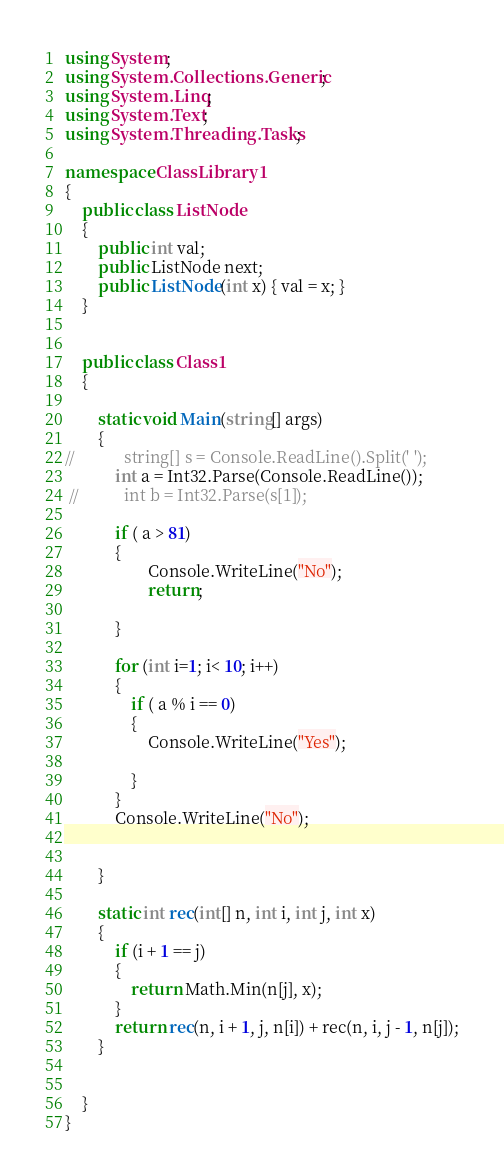Convert code to text. <code><loc_0><loc_0><loc_500><loc_500><_C#_>using System;
using System.Collections.Generic;
using System.Linq;
using System.Text;
using System.Threading.Tasks;

namespace ClassLibrary1
{
    public class ListNode
    {
        public int val;
        public ListNode next;
        public ListNode(int x) { val = x; }
    }


    public class Class1
    {

        static void Main(string[] args)
        {
//            string[] s = Console.ReadLine().Split(' ');
            int a = Int32.Parse(Console.ReadLine());
 //           int b = Int32.Parse(s[1]);

            if ( a > 81)
            {
                    Console.WriteLine("No");
                    return;

            }

            for (int i=1; i< 10; i++)
            {
                if ( a % i == 0)
                {
                    Console.WriteLine("Yes");

                }
            }
            Console.WriteLine("No");


        }

        static int rec(int[] n, int i, int j, int x)
        {
            if (i + 1 == j)
            {
                return Math.Min(n[j], x);
            }
            return rec(n, i + 1, j, n[i]) + rec(n, i, j - 1, n[j]);
        }


    }
}
</code> 